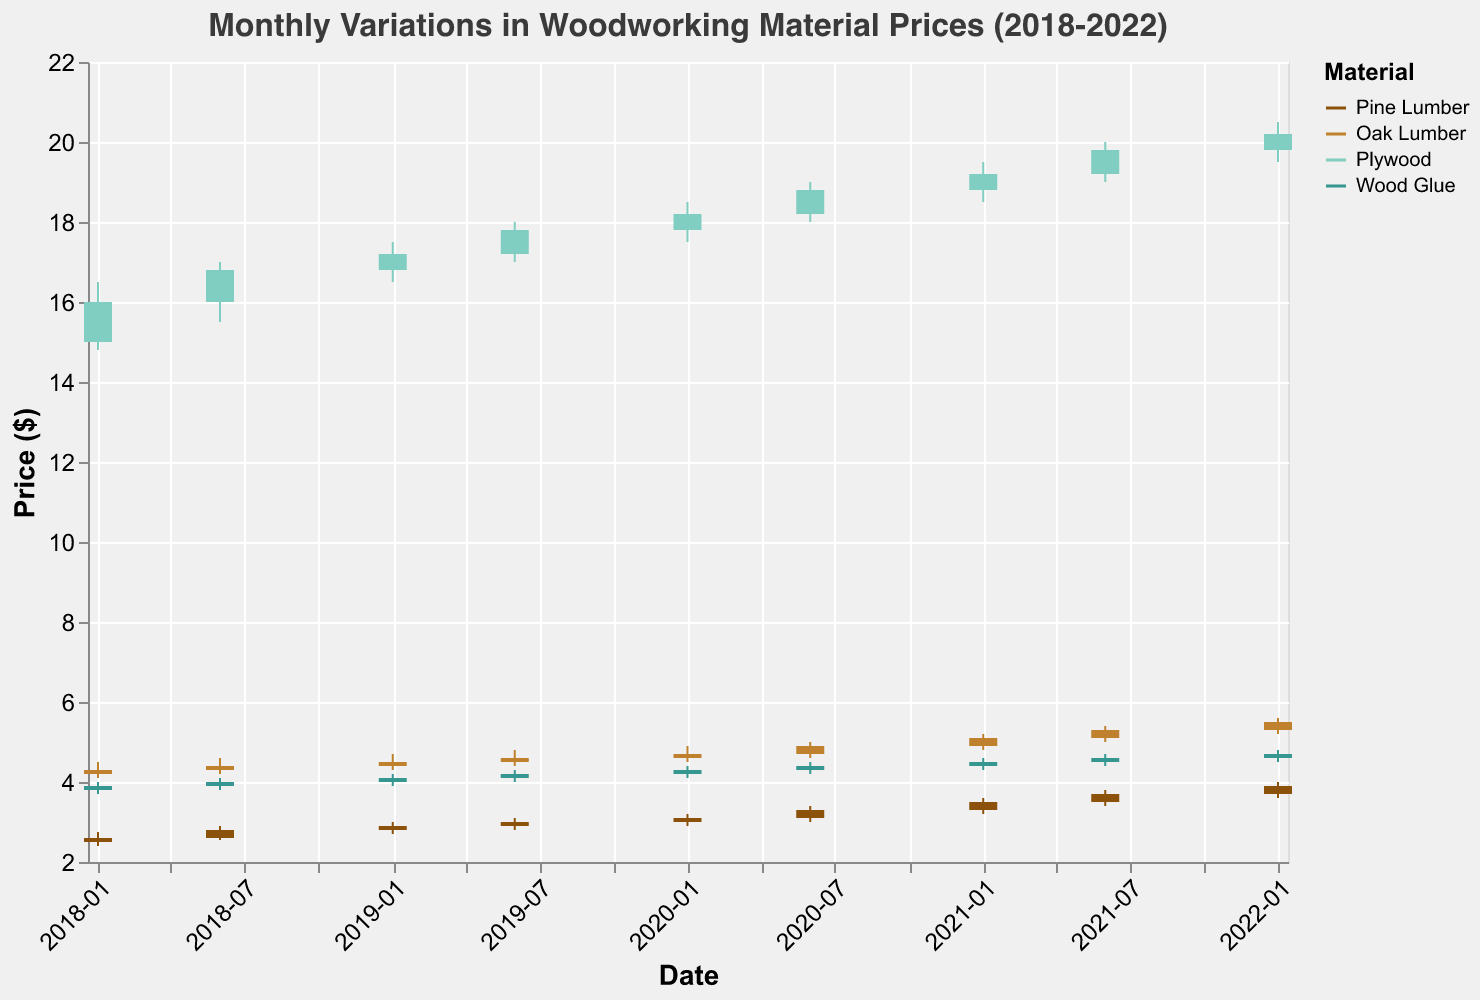How does the price of Pine Lumber change from January 2018 to January 2022? In January 2018, the closing price of Pine Lumber is $2.60. In January 2022, the closing price of Pine Lumber is $3.90. Therefore, it has increased by $1.30 over these five years.
Answer: It increased by $1.30 Which material had the highest overall price increase from January 2018 to January 2022? Let's consider the closing prices in January 2018 and January 2022. Pine Lumber increased from $2.60 to $3.90. Oak Lumber increased from $4.30 to $5.50. Plywood increased from $16.00 to $20.20. Wood Glue increased from $3.90 to $4.70. The price increase for each material is: Pine Lumber: $1.30, Oak Lumber: $1.20, Plywood: $4.20, Wood Glue: $0.80. Plywood had the highest price increase.
Answer: Plywood Was the price of Oak Lumber ever higher in June than in January for any year? We should compare the June and January closing prices for each year. In 2018, January: $4.30, June: $4.40. In 2019, January: $4.50, June: $4.60. In 2020, January: $4.70, June: $4.90. In 2021, January: $5.10, June: $5.30. In all years, the price in June is higher than in January.
Answer: Yes During which period did Wood Glue experience the smallest fluctuation (difference between high and low prices)? To find the period with the smallest fluctuation, we need to check the difference between the high and low prices for each period. Here are the differences: Jan 2018: $0.30, Jun 2018: $0.30, Jan 2019: $0.30, Jun 2019: $0.30, Jan 2020: $0.30, Jun 2020: $0.30, Jan 2021: $0.30, Jun 2021: $0.30, Jan 2022: $0.30. All periods have the same fluctuation of $0.30.
Answer: All periods are equal At its highest, what was the price of Plywood within the observed period? We need to look at the highest price of Plywood across all the data. The highest values for each period were Jan 2018: $16.50, Jun 2018: $17.00, Jan 2019: $17.50, Jun 2019: $18.00, Jan 2020: $18.50, Jun 2020: $19.00, Jan 2021: $19.50, Jun 2021: $20.00, Jan 2022: $20.50. The highest price of Plywood was $20.50 in January 2022.
Answer: $20.50 What is the trend in Wood Glue prices over the 5-year period observed? Observing the closing prices of Wood Glue from January 2018 to January 2022: Jan 2018: $3.90, Jan 2019: $4.10, Jan 2020: $4.30, Jan 2021: $4.50, Jan 2022: $4.70. The price shows a steady increase over the 5 years.
Answer: Steady increase In which year did Pine Lumber see the most significant price increase between January and June? We need to calculate the difference in closing prices between January and June for each year. 2018: Jan $2.60, Jun $2.80. Increase: $0.20. 2019: Jan $2.90, Jun $3.00. Increase: $0.10. 2020: Jan $3.10, Jun $3.30. Increase: $0.20. 2021: Jan $3.50, Jun $3.70. Increase: $0.20. The highest increase of $0.20 is seen in 2018, 2020, and 2021.
Answer: 2018, 2020, 2021 What is the average closing price of Oak Lumber over the 5-year period? We need to find the average of the closing prices for Oak Lumber across all observed periods. The closing prices are: Jan 2018: $4.30, Jun 2018: $4.40, Jan 2019: $4.50, Jun 2019: $4.60, Jan 2020: $4.70, Jun 2020: $4.90, Jan 2021: $5.10, Jun 2021: $5.30, Jan 2022: $5.50. The total sum is: 4.30 + 4.40 + 4.50 + 4.60 + 4.70 + 4.90 + 5.10 + 5.30 + 5.50 = 43.30. The average is 43.30 / 9 = $4.81.
Answer: $4.81 